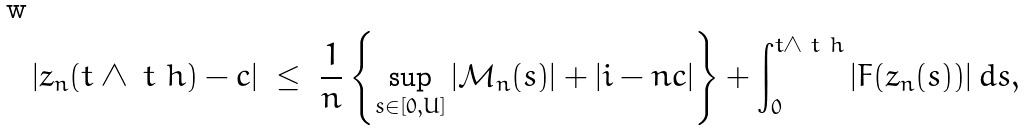Convert formula to latex. <formula><loc_0><loc_0><loc_500><loc_500>| z _ { n } ( t \wedge \ t _ { \ } h ) - c | \ \leq \ \frac { 1 } { n } \left \{ \sup _ { s \in [ 0 , U ] } | { \mathcal { M } } _ { n } ( s ) | + | i - n c | \right \} + \int _ { 0 } ^ { t \wedge \ t _ { \ } h } | F ( z _ { n } ( s ) ) | \, d s ,</formula> 